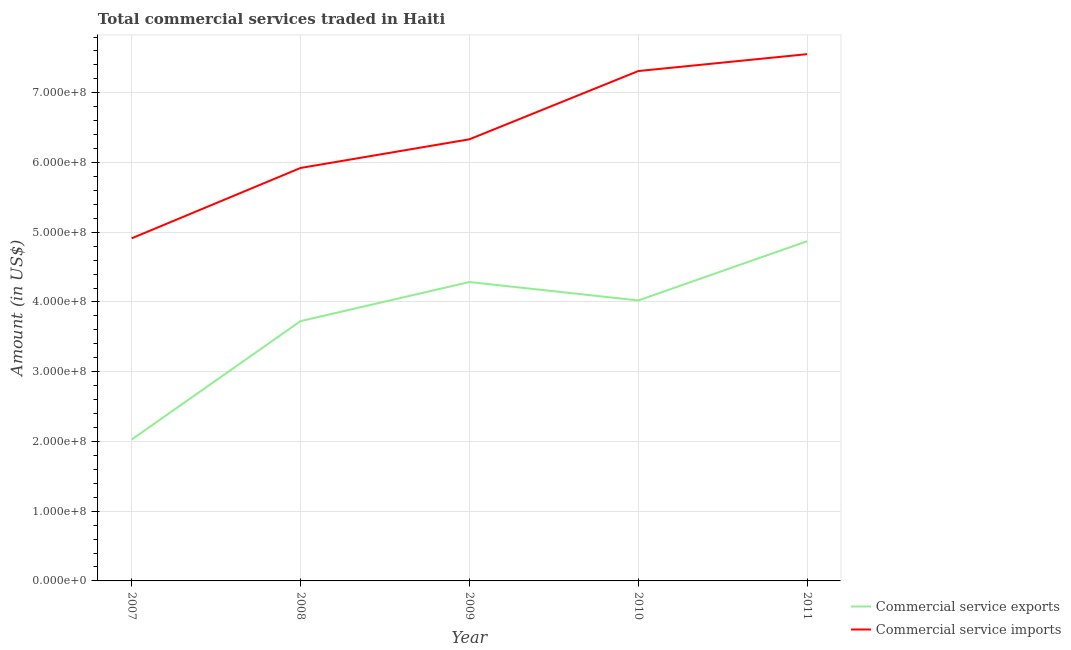How many different coloured lines are there?
Give a very brief answer. 2. Does the line corresponding to amount of commercial service exports intersect with the line corresponding to amount of commercial service imports?
Provide a succinct answer. No. What is the amount of commercial service exports in 2010?
Your answer should be compact. 4.02e+08. Across all years, what is the maximum amount of commercial service exports?
Your answer should be very brief. 4.87e+08. Across all years, what is the minimum amount of commercial service imports?
Keep it short and to the point. 4.91e+08. In which year was the amount of commercial service exports maximum?
Your answer should be compact. 2011. What is the total amount of commercial service imports in the graph?
Your answer should be compact. 3.20e+09. What is the difference between the amount of commercial service imports in 2007 and that in 2011?
Your answer should be compact. -2.64e+08. What is the difference between the amount of commercial service imports in 2010 and the amount of commercial service exports in 2008?
Provide a short and direct response. 3.59e+08. What is the average amount of commercial service exports per year?
Offer a terse response. 3.79e+08. In the year 2010, what is the difference between the amount of commercial service imports and amount of commercial service exports?
Provide a succinct answer. 3.29e+08. In how many years, is the amount of commercial service exports greater than 340000000 US$?
Your answer should be compact. 4. What is the ratio of the amount of commercial service imports in 2007 to that in 2011?
Your response must be concise. 0.65. What is the difference between the highest and the second highest amount of commercial service exports?
Provide a short and direct response. 5.85e+07. What is the difference between the highest and the lowest amount of commercial service exports?
Your answer should be compact. 2.84e+08. In how many years, is the amount of commercial service imports greater than the average amount of commercial service imports taken over all years?
Your answer should be very brief. 2. Does the amount of commercial service exports monotonically increase over the years?
Provide a short and direct response. No. Is the amount of commercial service exports strictly less than the amount of commercial service imports over the years?
Ensure brevity in your answer.  Yes. How many years are there in the graph?
Your response must be concise. 5. What is the difference between two consecutive major ticks on the Y-axis?
Your answer should be very brief. 1.00e+08. Are the values on the major ticks of Y-axis written in scientific E-notation?
Your answer should be compact. Yes. Does the graph contain grids?
Provide a succinct answer. Yes. How are the legend labels stacked?
Give a very brief answer. Vertical. What is the title of the graph?
Keep it short and to the point. Total commercial services traded in Haiti. Does "Formally registered" appear as one of the legend labels in the graph?
Give a very brief answer. No. What is the Amount (in US$) in Commercial service exports in 2007?
Your answer should be compact. 2.03e+08. What is the Amount (in US$) of Commercial service imports in 2007?
Offer a terse response. 4.91e+08. What is the Amount (in US$) of Commercial service exports in 2008?
Your answer should be compact. 3.73e+08. What is the Amount (in US$) of Commercial service imports in 2008?
Provide a succinct answer. 5.92e+08. What is the Amount (in US$) of Commercial service exports in 2009?
Your response must be concise. 4.29e+08. What is the Amount (in US$) in Commercial service imports in 2009?
Provide a succinct answer. 6.33e+08. What is the Amount (in US$) of Commercial service exports in 2010?
Ensure brevity in your answer.  4.02e+08. What is the Amount (in US$) in Commercial service imports in 2010?
Provide a succinct answer. 7.31e+08. What is the Amount (in US$) of Commercial service exports in 2011?
Provide a succinct answer. 4.87e+08. What is the Amount (in US$) of Commercial service imports in 2011?
Provide a succinct answer. 7.55e+08. Across all years, what is the maximum Amount (in US$) of Commercial service exports?
Your response must be concise. 4.87e+08. Across all years, what is the maximum Amount (in US$) of Commercial service imports?
Give a very brief answer. 7.55e+08. Across all years, what is the minimum Amount (in US$) of Commercial service exports?
Your answer should be very brief. 2.03e+08. Across all years, what is the minimum Amount (in US$) in Commercial service imports?
Give a very brief answer. 4.91e+08. What is the total Amount (in US$) of Commercial service exports in the graph?
Offer a very short reply. 1.89e+09. What is the total Amount (in US$) of Commercial service imports in the graph?
Give a very brief answer. 3.20e+09. What is the difference between the Amount (in US$) in Commercial service exports in 2007 and that in 2008?
Your answer should be very brief. -1.70e+08. What is the difference between the Amount (in US$) in Commercial service imports in 2007 and that in 2008?
Ensure brevity in your answer.  -1.01e+08. What is the difference between the Amount (in US$) in Commercial service exports in 2007 and that in 2009?
Give a very brief answer. -2.26e+08. What is the difference between the Amount (in US$) of Commercial service imports in 2007 and that in 2009?
Provide a succinct answer. -1.42e+08. What is the difference between the Amount (in US$) of Commercial service exports in 2007 and that in 2010?
Provide a short and direct response. -1.99e+08. What is the difference between the Amount (in US$) of Commercial service imports in 2007 and that in 2010?
Offer a very short reply. -2.40e+08. What is the difference between the Amount (in US$) of Commercial service exports in 2007 and that in 2011?
Your answer should be compact. -2.84e+08. What is the difference between the Amount (in US$) of Commercial service imports in 2007 and that in 2011?
Make the answer very short. -2.64e+08. What is the difference between the Amount (in US$) of Commercial service exports in 2008 and that in 2009?
Your response must be concise. -5.60e+07. What is the difference between the Amount (in US$) in Commercial service imports in 2008 and that in 2009?
Offer a terse response. -4.11e+07. What is the difference between the Amount (in US$) of Commercial service exports in 2008 and that in 2010?
Your answer should be very brief. -2.96e+07. What is the difference between the Amount (in US$) in Commercial service imports in 2008 and that in 2010?
Offer a terse response. -1.39e+08. What is the difference between the Amount (in US$) of Commercial service exports in 2008 and that in 2011?
Keep it short and to the point. -1.15e+08. What is the difference between the Amount (in US$) of Commercial service imports in 2008 and that in 2011?
Provide a succinct answer. -1.63e+08. What is the difference between the Amount (in US$) of Commercial service exports in 2009 and that in 2010?
Offer a very short reply. 2.64e+07. What is the difference between the Amount (in US$) of Commercial service imports in 2009 and that in 2010?
Your answer should be very brief. -9.79e+07. What is the difference between the Amount (in US$) of Commercial service exports in 2009 and that in 2011?
Provide a short and direct response. -5.85e+07. What is the difference between the Amount (in US$) in Commercial service imports in 2009 and that in 2011?
Make the answer very short. -1.22e+08. What is the difference between the Amount (in US$) in Commercial service exports in 2010 and that in 2011?
Give a very brief answer. -8.49e+07. What is the difference between the Amount (in US$) of Commercial service imports in 2010 and that in 2011?
Provide a succinct answer. -2.42e+07. What is the difference between the Amount (in US$) in Commercial service exports in 2007 and the Amount (in US$) in Commercial service imports in 2008?
Ensure brevity in your answer.  -3.89e+08. What is the difference between the Amount (in US$) of Commercial service exports in 2007 and the Amount (in US$) of Commercial service imports in 2009?
Your response must be concise. -4.31e+08. What is the difference between the Amount (in US$) in Commercial service exports in 2007 and the Amount (in US$) in Commercial service imports in 2010?
Give a very brief answer. -5.28e+08. What is the difference between the Amount (in US$) of Commercial service exports in 2007 and the Amount (in US$) of Commercial service imports in 2011?
Ensure brevity in your answer.  -5.53e+08. What is the difference between the Amount (in US$) in Commercial service exports in 2008 and the Amount (in US$) in Commercial service imports in 2009?
Your answer should be very brief. -2.61e+08. What is the difference between the Amount (in US$) of Commercial service exports in 2008 and the Amount (in US$) of Commercial service imports in 2010?
Offer a very short reply. -3.59e+08. What is the difference between the Amount (in US$) in Commercial service exports in 2008 and the Amount (in US$) in Commercial service imports in 2011?
Provide a short and direct response. -3.83e+08. What is the difference between the Amount (in US$) in Commercial service exports in 2009 and the Amount (in US$) in Commercial service imports in 2010?
Provide a succinct answer. -3.03e+08. What is the difference between the Amount (in US$) of Commercial service exports in 2009 and the Amount (in US$) of Commercial service imports in 2011?
Keep it short and to the point. -3.27e+08. What is the difference between the Amount (in US$) in Commercial service exports in 2010 and the Amount (in US$) in Commercial service imports in 2011?
Your answer should be compact. -3.53e+08. What is the average Amount (in US$) in Commercial service exports per year?
Offer a very short reply. 3.79e+08. What is the average Amount (in US$) of Commercial service imports per year?
Give a very brief answer. 6.41e+08. In the year 2007, what is the difference between the Amount (in US$) in Commercial service exports and Amount (in US$) in Commercial service imports?
Your answer should be compact. -2.89e+08. In the year 2008, what is the difference between the Amount (in US$) of Commercial service exports and Amount (in US$) of Commercial service imports?
Make the answer very short. -2.20e+08. In the year 2009, what is the difference between the Amount (in US$) of Commercial service exports and Amount (in US$) of Commercial service imports?
Give a very brief answer. -2.05e+08. In the year 2010, what is the difference between the Amount (in US$) of Commercial service exports and Amount (in US$) of Commercial service imports?
Provide a short and direct response. -3.29e+08. In the year 2011, what is the difference between the Amount (in US$) in Commercial service exports and Amount (in US$) in Commercial service imports?
Give a very brief answer. -2.68e+08. What is the ratio of the Amount (in US$) of Commercial service exports in 2007 to that in 2008?
Offer a terse response. 0.54. What is the ratio of the Amount (in US$) in Commercial service imports in 2007 to that in 2008?
Your response must be concise. 0.83. What is the ratio of the Amount (in US$) of Commercial service exports in 2007 to that in 2009?
Your answer should be very brief. 0.47. What is the ratio of the Amount (in US$) of Commercial service imports in 2007 to that in 2009?
Provide a short and direct response. 0.78. What is the ratio of the Amount (in US$) in Commercial service exports in 2007 to that in 2010?
Keep it short and to the point. 0.5. What is the ratio of the Amount (in US$) of Commercial service imports in 2007 to that in 2010?
Offer a terse response. 0.67. What is the ratio of the Amount (in US$) of Commercial service exports in 2007 to that in 2011?
Make the answer very short. 0.42. What is the ratio of the Amount (in US$) of Commercial service imports in 2007 to that in 2011?
Offer a terse response. 0.65. What is the ratio of the Amount (in US$) in Commercial service exports in 2008 to that in 2009?
Give a very brief answer. 0.87. What is the ratio of the Amount (in US$) of Commercial service imports in 2008 to that in 2009?
Offer a very short reply. 0.94. What is the ratio of the Amount (in US$) of Commercial service exports in 2008 to that in 2010?
Offer a very short reply. 0.93. What is the ratio of the Amount (in US$) of Commercial service imports in 2008 to that in 2010?
Provide a succinct answer. 0.81. What is the ratio of the Amount (in US$) of Commercial service exports in 2008 to that in 2011?
Give a very brief answer. 0.76. What is the ratio of the Amount (in US$) of Commercial service imports in 2008 to that in 2011?
Your answer should be compact. 0.78. What is the ratio of the Amount (in US$) in Commercial service exports in 2009 to that in 2010?
Offer a very short reply. 1.07. What is the ratio of the Amount (in US$) of Commercial service imports in 2009 to that in 2010?
Provide a succinct answer. 0.87. What is the ratio of the Amount (in US$) of Commercial service exports in 2009 to that in 2011?
Offer a terse response. 0.88. What is the ratio of the Amount (in US$) of Commercial service imports in 2009 to that in 2011?
Your answer should be compact. 0.84. What is the ratio of the Amount (in US$) of Commercial service exports in 2010 to that in 2011?
Your answer should be compact. 0.83. What is the ratio of the Amount (in US$) in Commercial service imports in 2010 to that in 2011?
Provide a short and direct response. 0.97. What is the difference between the highest and the second highest Amount (in US$) of Commercial service exports?
Ensure brevity in your answer.  5.85e+07. What is the difference between the highest and the second highest Amount (in US$) of Commercial service imports?
Make the answer very short. 2.42e+07. What is the difference between the highest and the lowest Amount (in US$) in Commercial service exports?
Ensure brevity in your answer.  2.84e+08. What is the difference between the highest and the lowest Amount (in US$) in Commercial service imports?
Your response must be concise. 2.64e+08. 